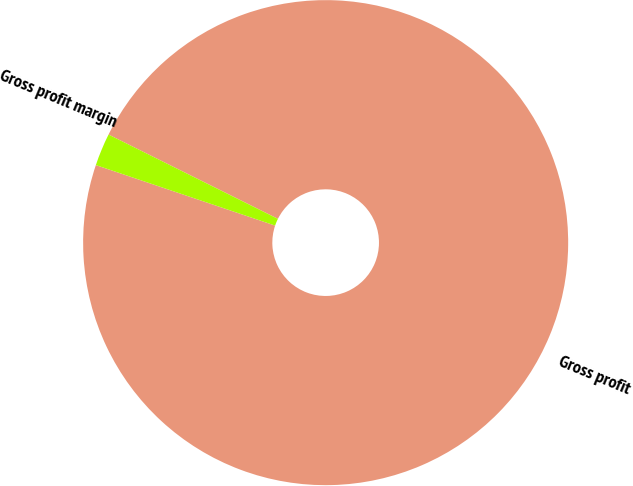Convert chart. <chart><loc_0><loc_0><loc_500><loc_500><pie_chart><fcel>Gross profit<fcel>Gross profit margin<nl><fcel>97.83%<fcel>2.17%<nl></chart> 